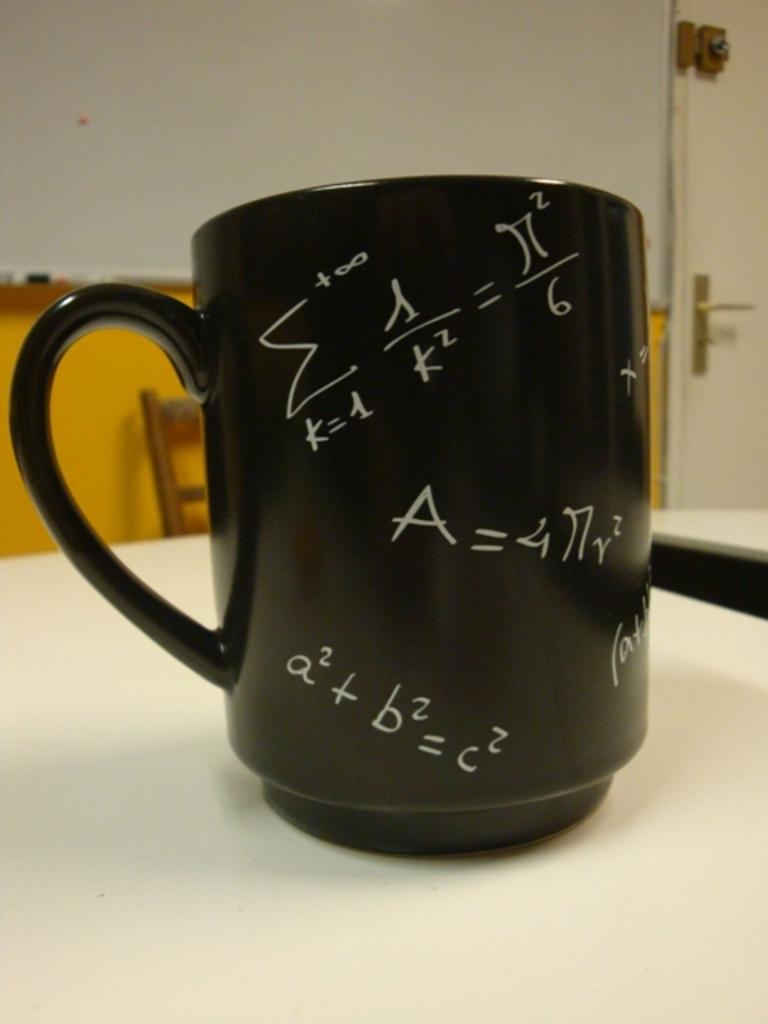<image>
Describe the image concisely. A coffee mug with a2 +b2=c2 and a few other math problems all over it 